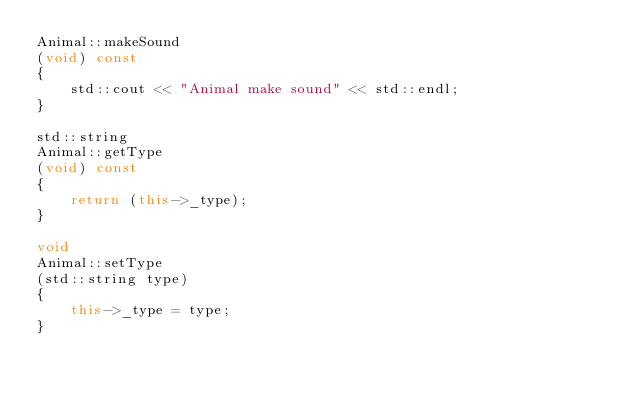Convert code to text. <code><loc_0><loc_0><loc_500><loc_500><_C++_>Animal::makeSound
(void) const
{
	std::cout << "Animal make sound" << std::endl;
}

std::string
Animal::getType
(void) const
{
	return (this->_type);
}

void
Animal::setType
(std::string type)
{
	this->_type = type;
}

</code> 